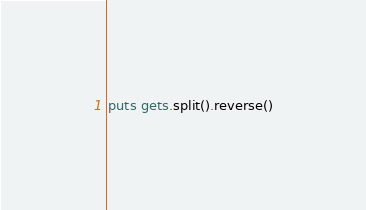Convert code to text. <code><loc_0><loc_0><loc_500><loc_500><_Ruby_>puts gets.split().reverse()</code> 